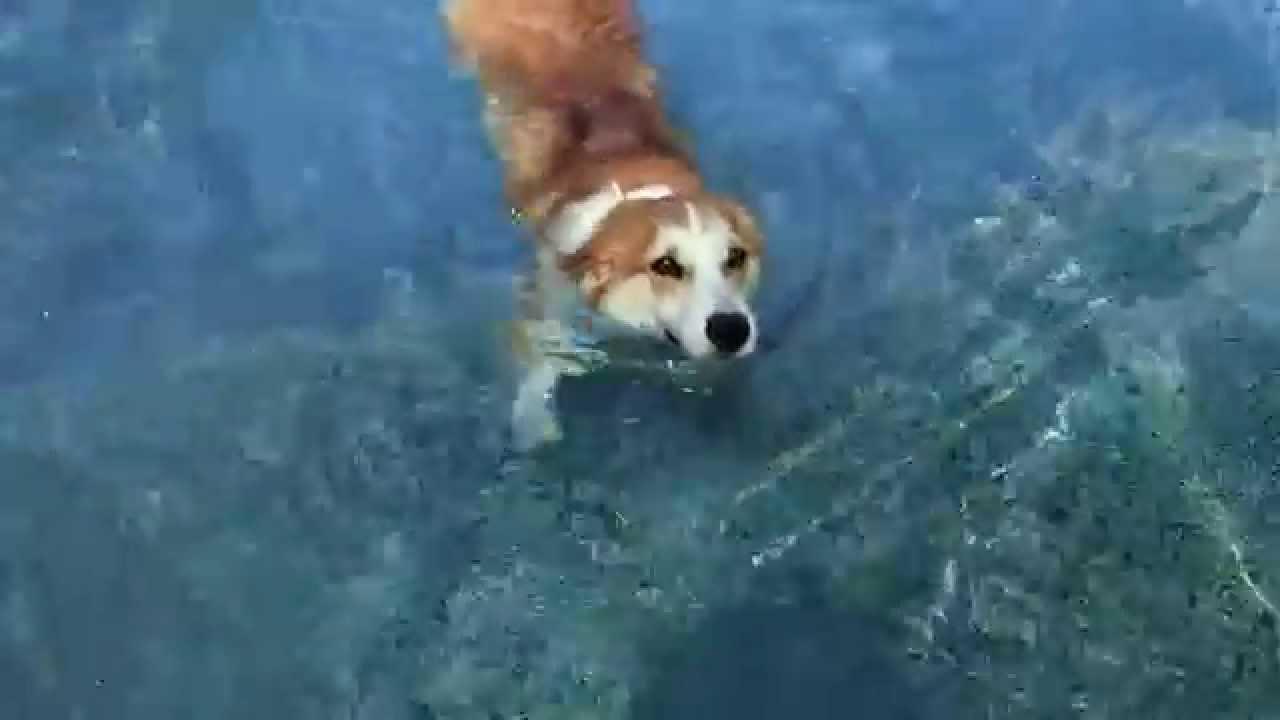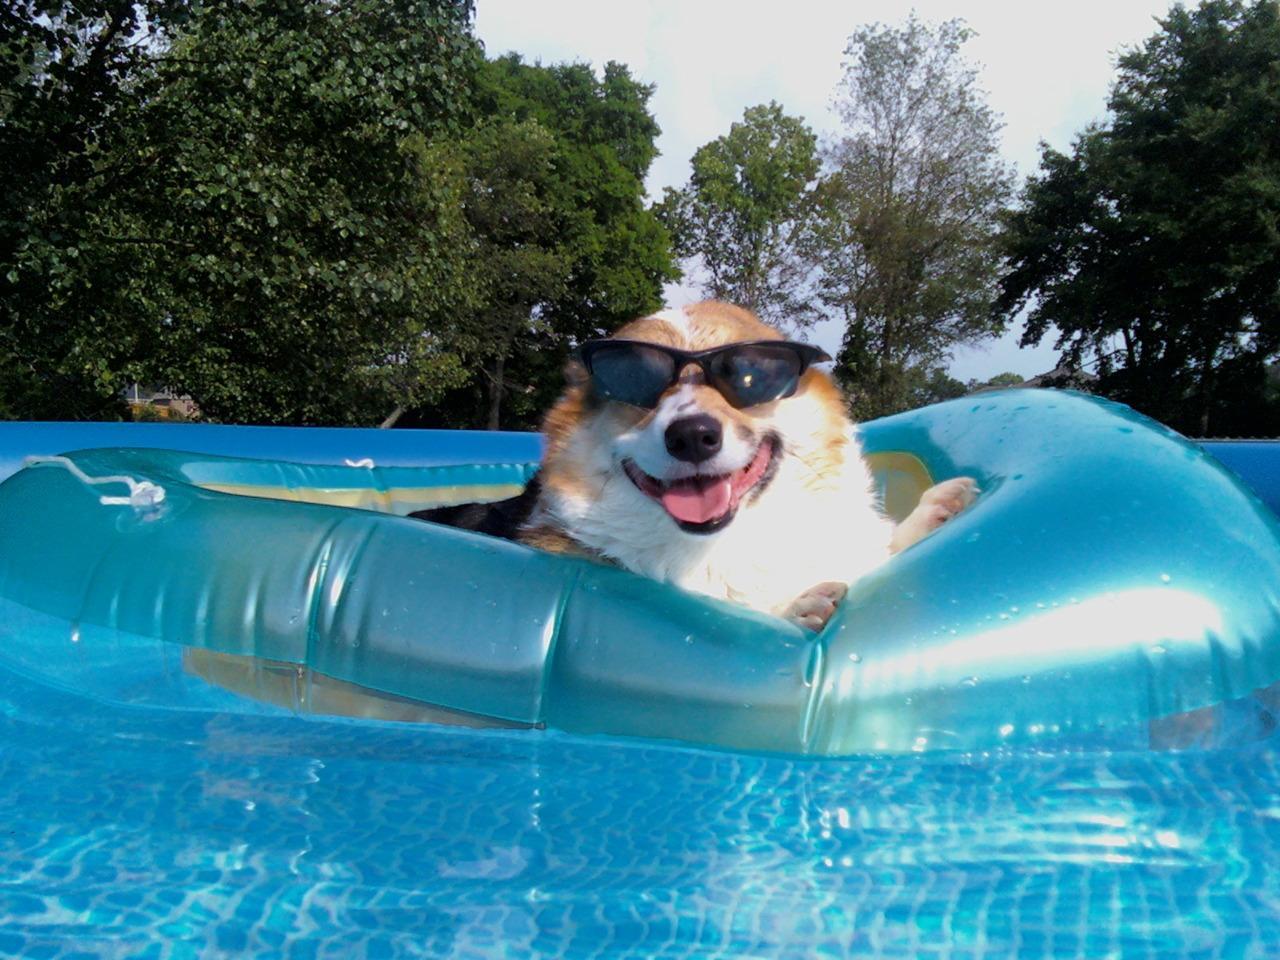The first image is the image on the left, the second image is the image on the right. Evaluate the accuracy of this statement regarding the images: "there is at least one corgi in a pool on an inflatable mat wearing sunglasses with it's tongue sticking out". Is it true? Answer yes or no. Yes. 